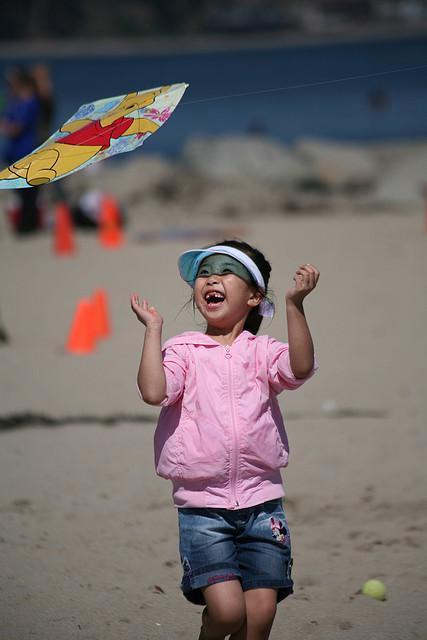How many balls in picture?
Give a very brief answer. 1. How many people can you see?
Give a very brief answer. 2. How many elephants are in this photo?
Give a very brief answer. 0. 